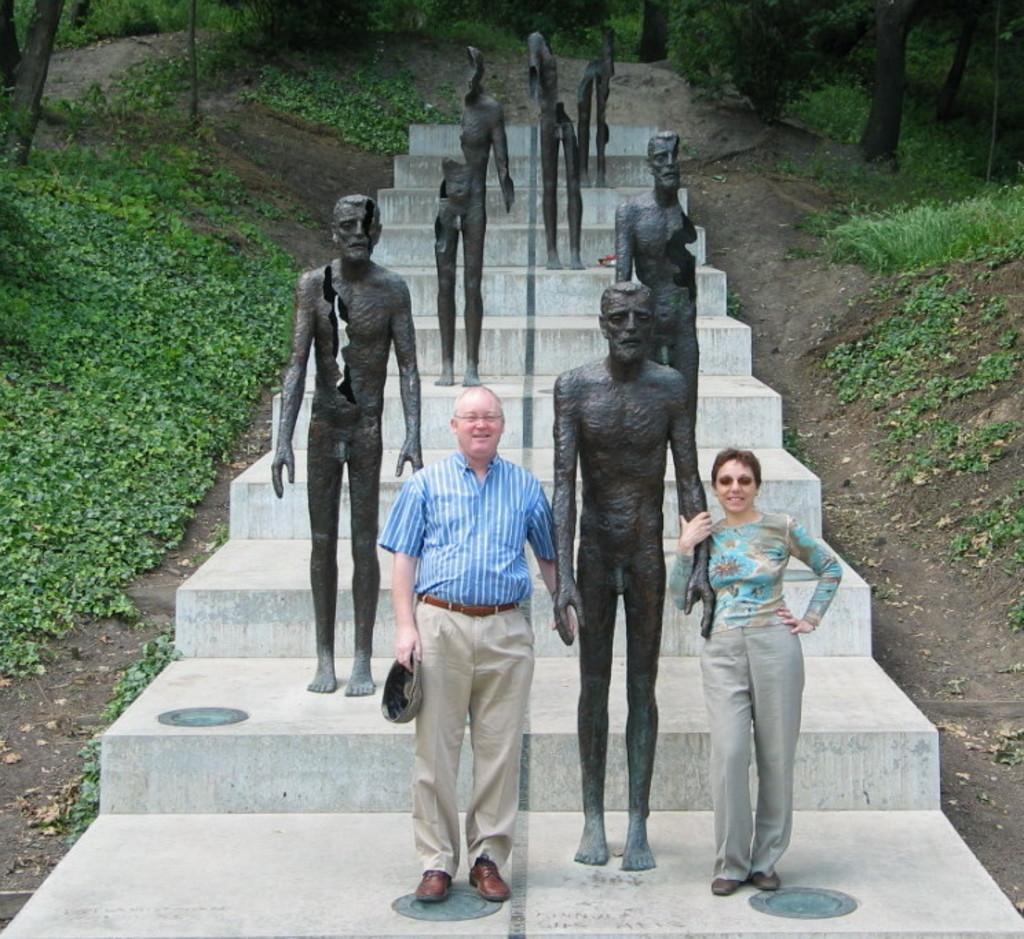Could you give a brief overview of what you see in this image? In this picture we can see two persons standing, there are some statues and stairs in the middle, there are some plants and trees in the background. 